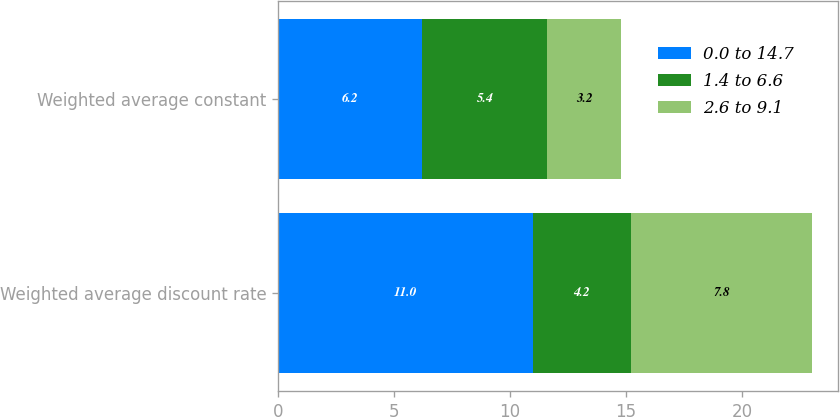<chart> <loc_0><loc_0><loc_500><loc_500><stacked_bar_chart><ecel><fcel>Weighted average discount rate<fcel>Weighted average constant<nl><fcel>0.0 to 14.7<fcel>11<fcel>6.2<nl><fcel>1.4 to 6.6<fcel>4.2<fcel>5.4<nl><fcel>2.6 to 9.1<fcel>7.8<fcel>3.2<nl></chart> 